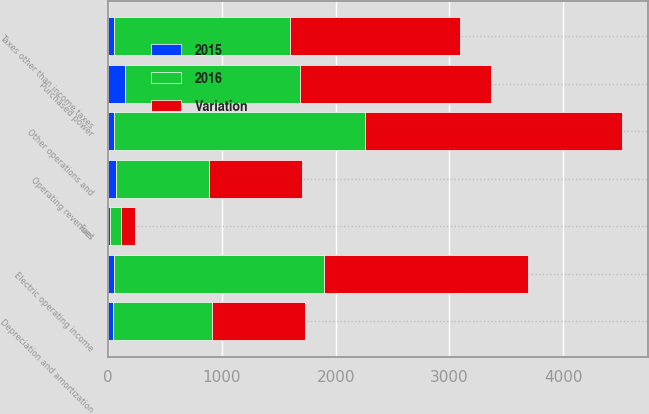Convert chart. <chart><loc_0><loc_0><loc_500><loc_500><stacked_bar_chart><ecel><fcel>Operating revenues<fcel>Purchased power<fcel>Fuel<fcel>Other operations and<fcel>Depreciation and amortization<fcel>Taxes other than income taxes<fcel>Electric operating income<nl><fcel>2016<fcel>820<fcel>1533<fcel>104<fcel>2210<fcel>865<fcel>1547<fcel>1847<nl><fcel>Variation<fcel>820<fcel>1684<fcel>118<fcel>2259<fcel>820<fcel>1493<fcel>1798<nl><fcel>2015<fcel>66<fcel>151<fcel>14<fcel>49<fcel>45<fcel>54<fcel>49<nl></chart> 